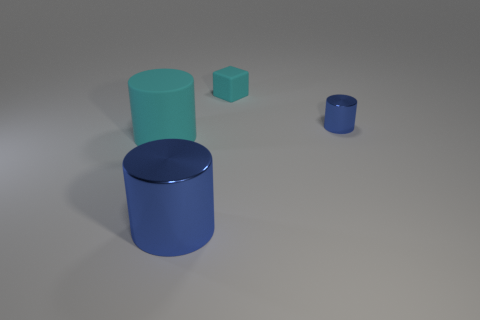There is a object that is in front of the large cyan thing; is it the same color as the big rubber thing?
Your answer should be very brief. No. What is the material of the small thing that is the same color as the big shiny cylinder?
Ensure brevity in your answer.  Metal. Do the blue thing in front of the cyan rubber cylinder and the large cyan matte cylinder have the same size?
Your answer should be compact. Yes. Is there a tiny object that has the same color as the large metallic cylinder?
Ensure brevity in your answer.  Yes. Are there any big cyan cylinders in front of the blue thing on the left side of the small cyan object?
Give a very brief answer. No. Is there a small thing that has the same material as the tiny cylinder?
Make the answer very short. No. There is a big thing that is to the right of the cyan rubber thing that is to the left of the large metal cylinder; what is it made of?
Give a very brief answer. Metal. What is the material of the thing that is right of the large shiny thing and in front of the cyan block?
Make the answer very short. Metal. Is the number of large metal cylinders in front of the large shiny cylinder the same as the number of cyan blocks?
Your answer should be compact. No. How many other large cyan objects have the same shape as the large cyan thing?
Make the answer very short. 0. 